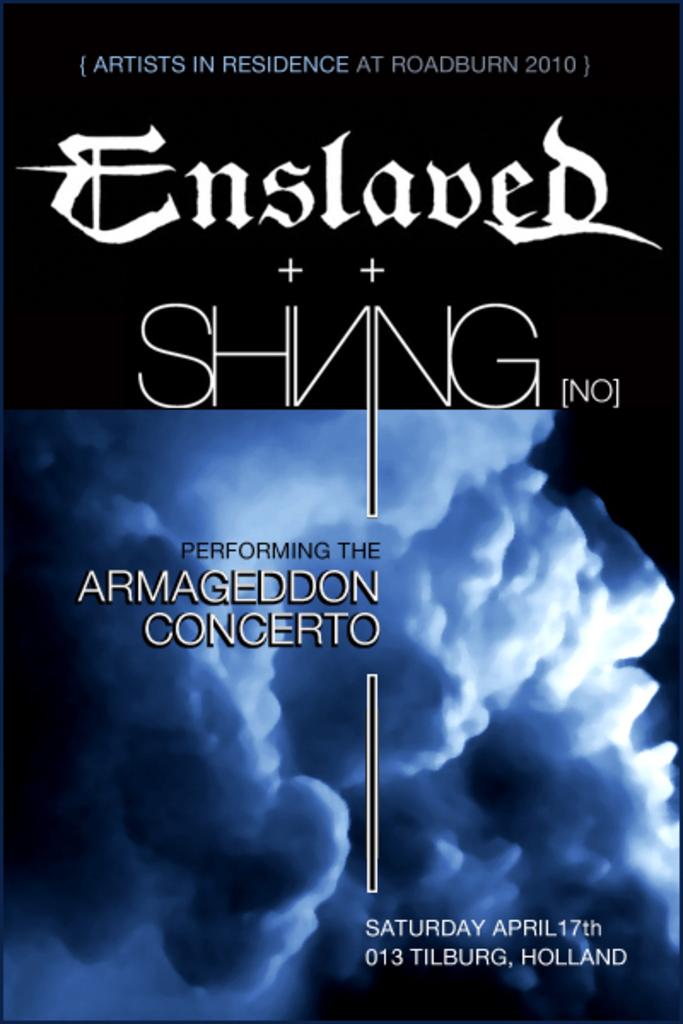Is this being held on a saturday?
Make the answer very short. Yes. 